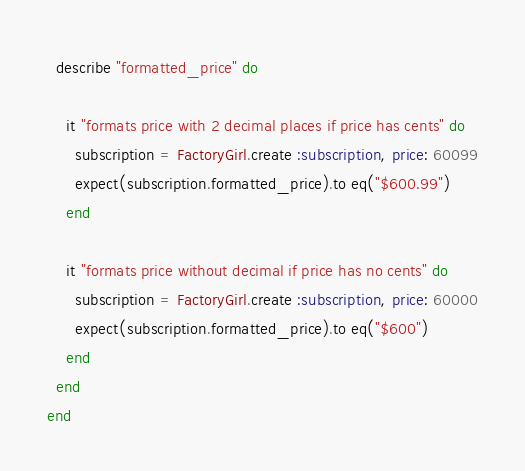Convert code to text. <code><loc_0><loc_0><loc_500><loc_500><_Ruby_>  describe "formatted_price" do

    it "formats price with 2 decimal places if price has cents" do
      subscription = FactoryGirl.create :subscription, price: 60099
      expect(subscription.formatted_price).to eq("$600.99")
    end

    it "formats price without decimal if price has no cents" do
      subscription = FactoryGirl.create :subscription, price: 60000
      expect(subscription.formatted_price).to eq("$600")
    end
  end
end
</code> 